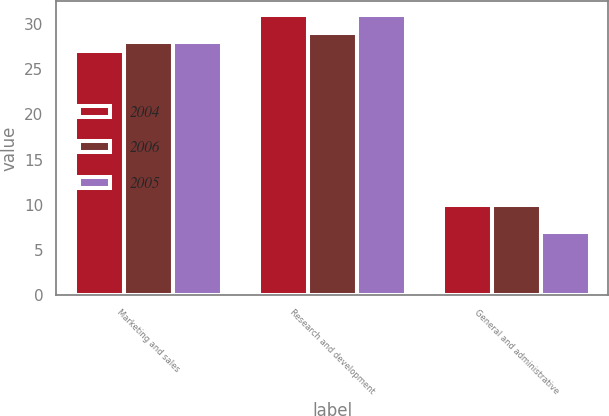Convert chart. <chart><loc_0><loc_0><loc_500><loc_500><stacked_bar_chart><ecel><fcel>Marketing and sales<fcel>Research and development<fcel>General and administrative<nl><fcel>2004<fcel>27<fcel>31<fcel>10<nl><fcel>2006<fcel>28<fcel>29<fcel>10<nl><fcel>2005<fcel>28<fcel>31<fcel>7<nl></chart> 